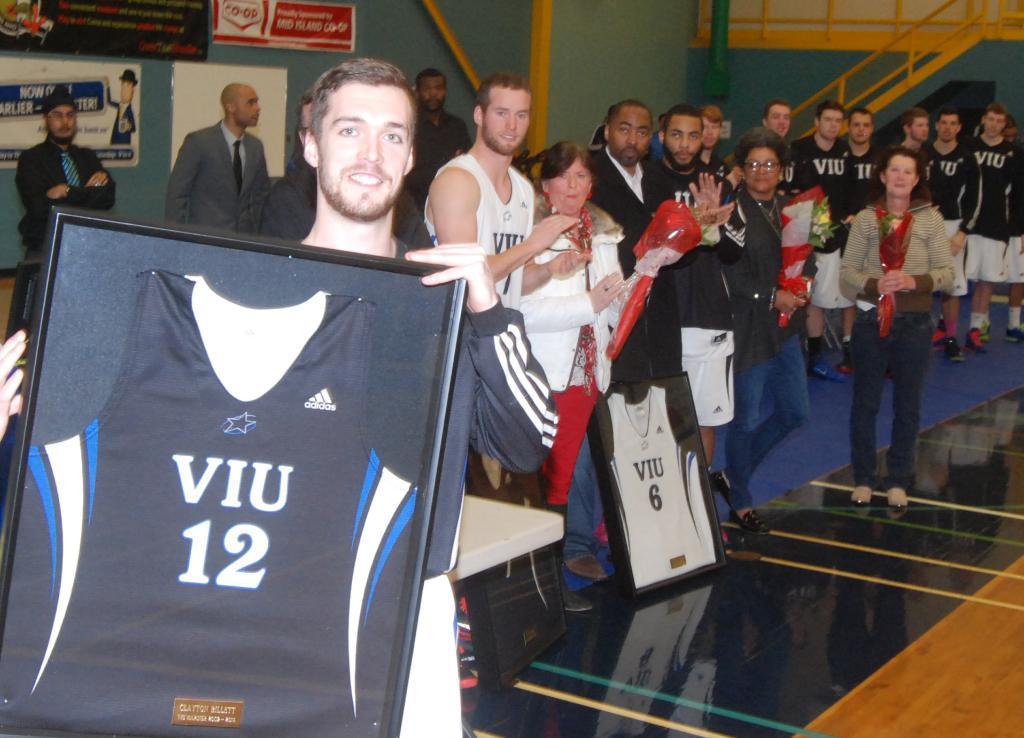What number is on the white jersey in the frame?
Make the answer very short. 12. 